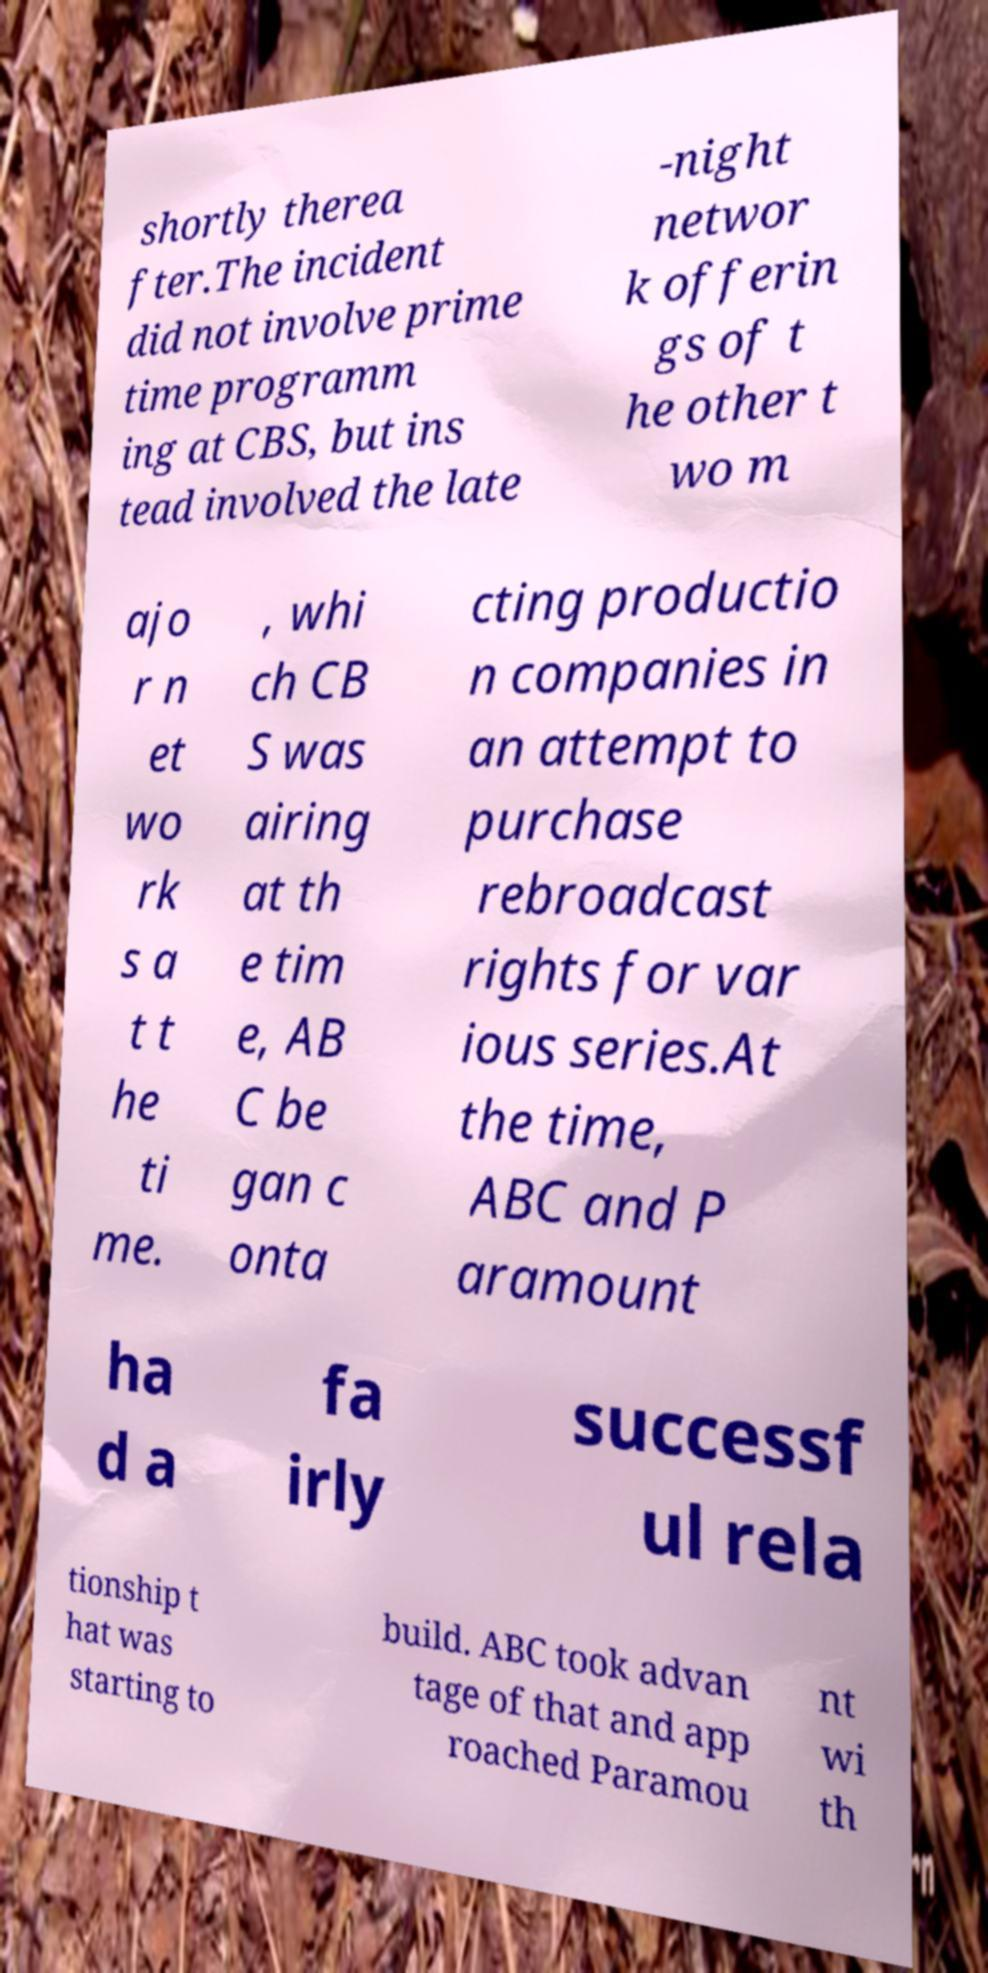For documentation purposes, I need the text within this image transcribed. Could you provide that? shortly therea fter.The incident did not involve prime time programm ing at CBS, but ins tead involved the late -night networ k offerin gs of t he other t wo m ajo r n et wo rk s a t t he ti me. , whi ch CB S was airing at th e tim e, AB C be gan c onta cting productio n companies in an attempt to purchase rebroadcast rights for var ious series.At the time, ABC and P aramount ha d a fa irly successf ul rela tionship t hat was starting to build. ABC took advan tage of that and app roached Paramou nt wi th 